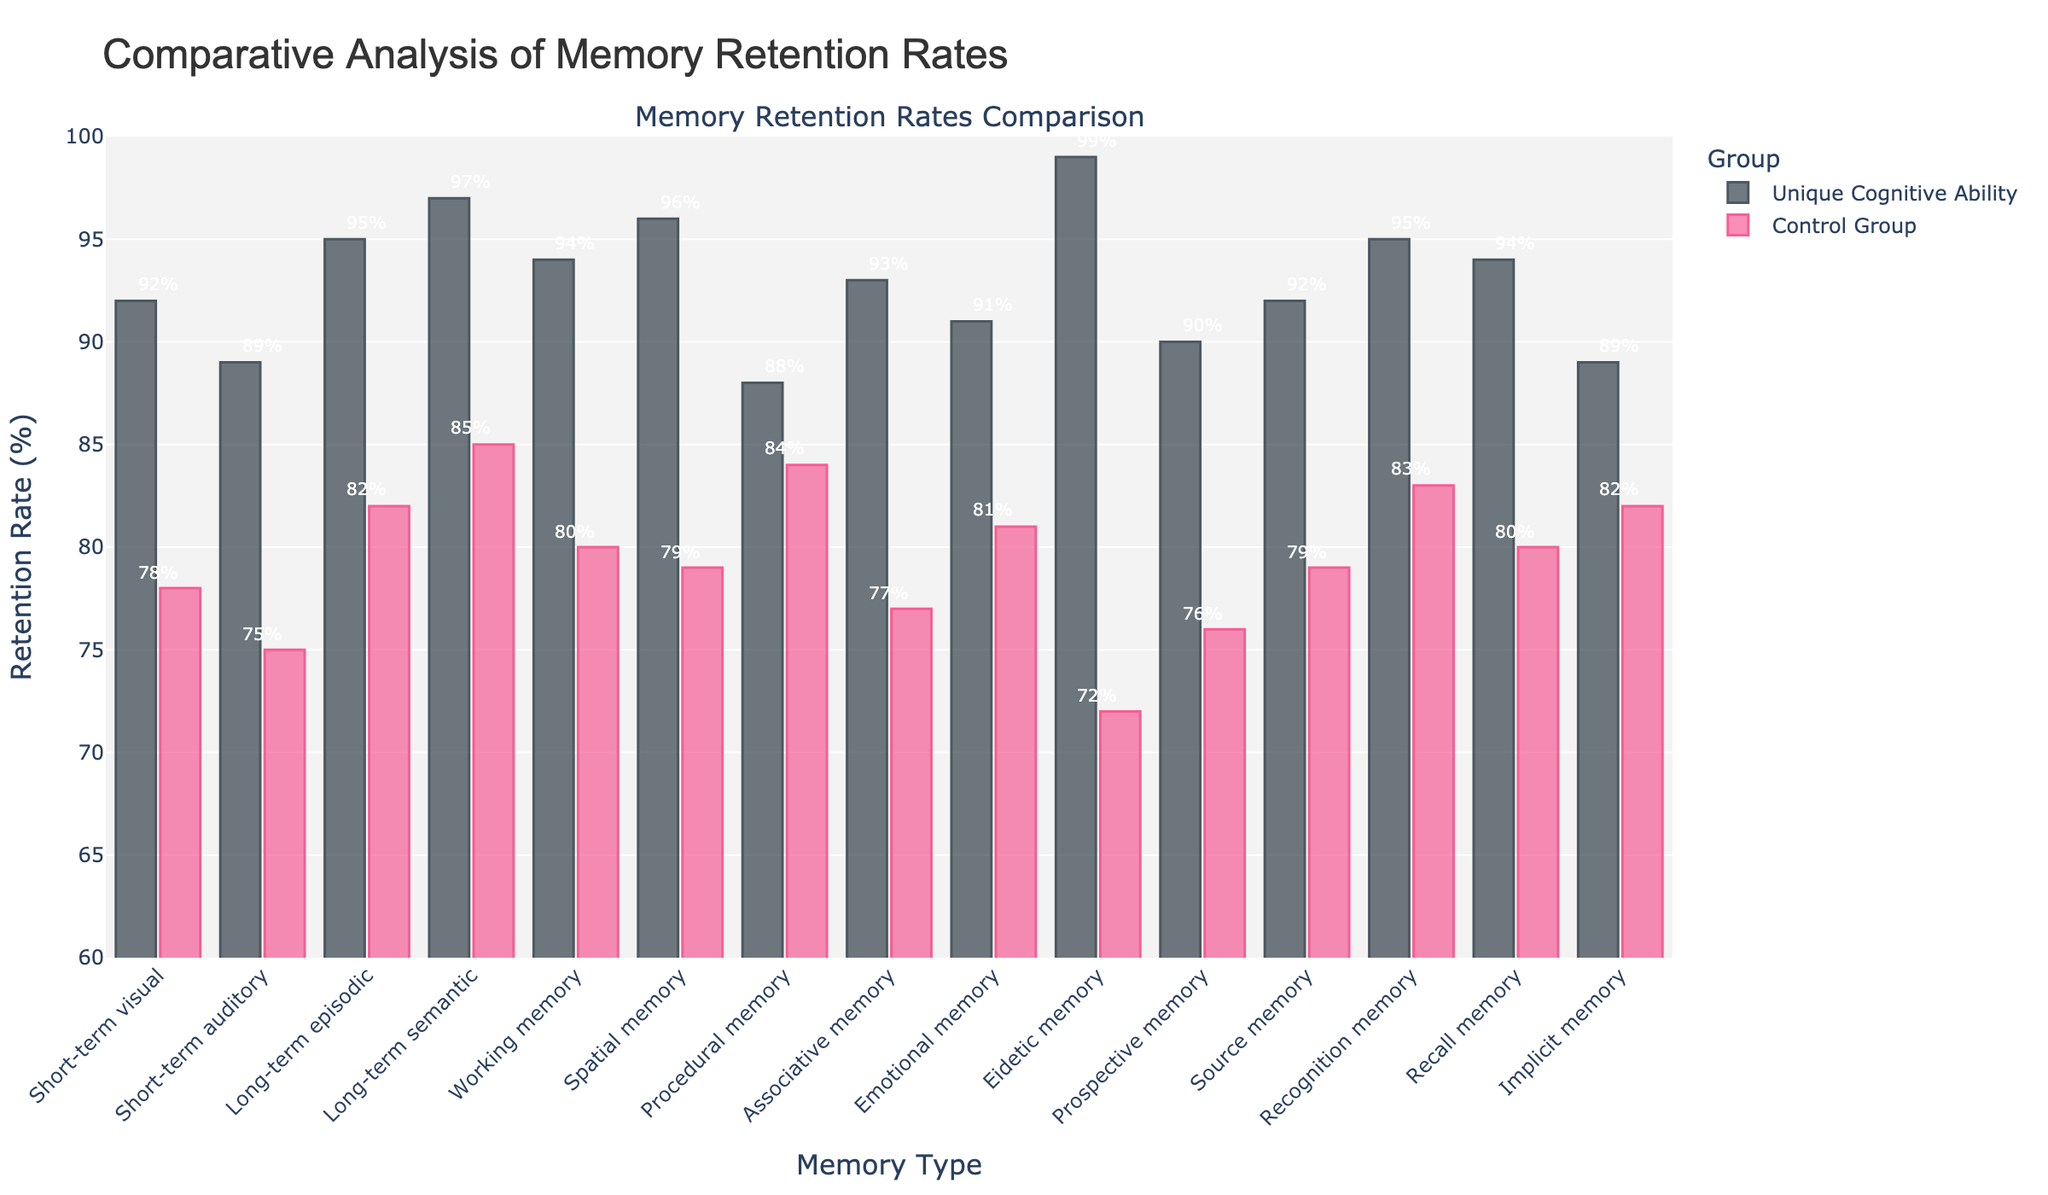What is the highest retention rate for the control group? To find the highest retention rate for the control group, scan through all the percent values in the control group column. The highest value is 85% under "Long-term semantic memory". Therefore, the highest retention rate for the control group is 85%.
Answer: 85% Which memory type shows the greatest difference in retention rates between the unique cognitive ability group and the control group? To determine the greatest difference, subtract the retention rate of the control group from the unique cognitive ability group's rate for each memory type. The difference for "Eidetic memory" is the highest ((99-72) = 27%). Therefore, the memory type with the greatest difference is "Eidetic memory".
Answer: Eidetic memory In which memory type does the control group show better performance than the unique cognitive ability group? Compare rates for all memory types between both groups. The control group outperforms in "Procedural memory" (88% vs 84%). Therefore, the control group shows better performance in "Procedural memory".
Answer: Procedural memory What is the average retention rate for the unique cognitive ability group across all memory types? Sum the retention rates for the unique cognitive ability group and divide by the total number of memory types. The calculation is (92+89+95+97+94+96+88+93+91+99+90+92+95+94+89)/15 = 93.13%. Therefore, the average retention rate for the unique cognitive ability group is 93.13%.
Answer: 93.13% Which memory type has the smallest gap in retention rates between both groups? Calculate the gap for each memory type by subtracting the retention rates of the control group from the unique cognitive ability group. "Procedural memory" has the smallest gap ((88-84) = 4%). Thus, the smallest gap is in "Procedural memory".
Answer: Procedural memory How much higher is the retention rate for "Recognition memory" in the unique cognitive ability group compared to the control group? "Recognition memory" retention rates are 95% for the unique cognitive ability group and 83% for the control group. The difference is (95-83) = 12%. Therefore, the retention rate is 12% higher.
Answer: 12% Which group has a higher retention rate for "Emotional memory," and by how much? Compare retention rates for "Emotional memory". The unique cognitive ability group has 91%, while the control group has 81%. Calculate the difference: (91-81) = 10%. So, the unique cognitive ability group is higher by 10%.
Answer: Unique cognitive ability group, 10% What is the least common retention rate for the unique cognitive ability group? List all retention rates for the unique cognitive ability group and identify the least common rate. The least common retention rate is 89%.
Answer: 89% Based on the visual attributes, which group tends to have taller bars in the chart? Observing the chart, the unique cognitive ability group consistently has taller bars than the control group in most memory types, indicating higher retention rates.
Answer: Unique cognitive ability group What is the sum of the retention rates for "Long-term episodic" and "Long-term semantic" memories for both groups? Add the rates for these memory types for both groups. Unique ability: 95 (episodic) + 97 (semantic) = 192%, Control group: 82 (episodic) + 85 (semantic) = 167%. Thus, the sums are 192% and 167%.
Answer: 192%, 167% 